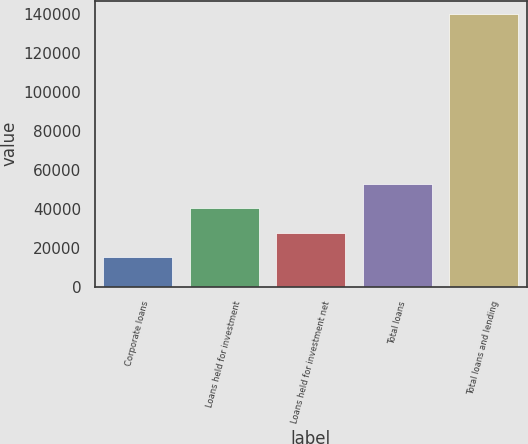<chart> <loc_0><loc_0><loc_500><loc_500><bar_chart><fcel>Corporate loans<fcel>Loans held for investment<fcel>Loans held for investment net<fcel>Total loans<fcel>Total loans and lending<nl><fcel>15332<fcel>40179.8<fcel>27755.9<fcel>52603.7<fcel>139571<nl></chart> 